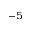Convert formula to latex. <formula><loc_0><loc_0><loc_500><loc_500>^ { - 5 }</formula> 